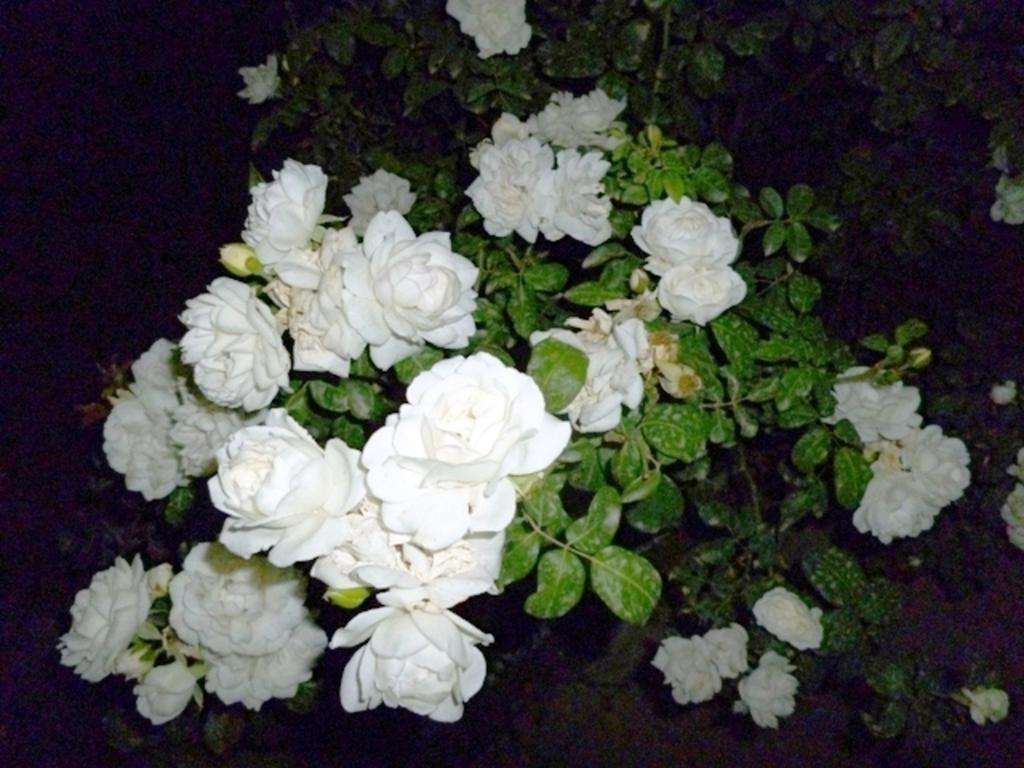What type of living organisms can be seen in the image? Plants and flowers can be seen in the image. What stage of growth are some of the plants in the image? There are buds in the image, which suggests that some of the plants are in the early stages of growth. What is the color of the background in the image? The background of the image is dark. What type of ink can be seen dripping from the appliance in the image? There is no appliance or ink present in the image; it features plants, flowers, and buds with a dark background. 